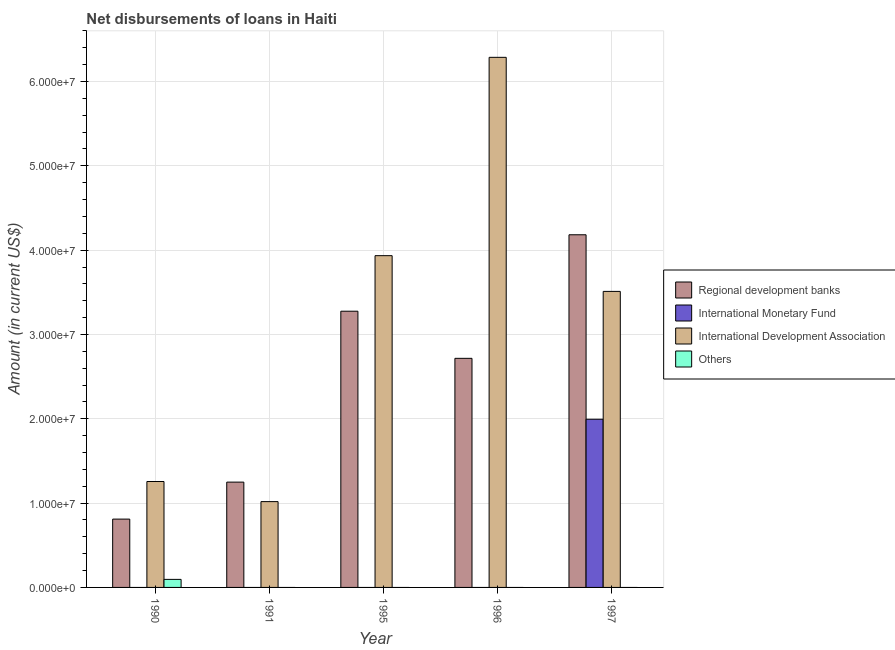How many different coloured bars are there?
Provide a short and direct response. 4. How many groups of bars are there?
Your response must be concise. 5. Are the number of bars per tick equal to the number of legend labels?
Your answer should be very brief. No. Are the number of bars on each tick of the X-axis equal?
Provide a short and direct response. No. How many bars are there on the 2nd tick from the left?
Give a very brief answer. 2. Across all years, what is the maximum amount of loan disimbursed by international monetary fund?
Keep it short and to the point. 1.99e+07. In which year was the amount of loan disimbursed by international monetary fund maximum?
Keep it short and to the point. 1997. What is the total amount of loan disimbursed by international monetary fund in the graph?
Keep it short and to the point. 1.99e+07. What is the difference between the amount of loan disimbursed by regional development banks in 1990 and that in 1991?
Your response must be concise. -4.38e+06. What is the difference between the amount of loan disimbursed by regional development banks in 1995 and the amount of loan disimbursed by international monetary fund in 1990?
Ensure brevity in your answer.  2.47e+07. What is the average amount of loan disimbursed by regional development banks per year?
Make the answer very short. 2.45e+07. What is the ratio of the amount of loan disimbursed by regional development banks in 1995 to that in 1997?
Ensure brevity in your answer.  0.78. Is the amount of loan disimbursed by international development association in 1996 less than that in 1997?
Your answer should be very brief. No. Is the difference between the amount of loan disimbursed by international development association in 1991 and 1995 greater than the difference between the amount of loan disimbursed by international monetary fund in 1991 and 1995?
Your response must be concise. No. What is the difference between the highest and the second highest amount of loan disimbursed by international development association?
Your answer should be compact. 2.35e+07. What is the difference between the highest and the lowest amount of loan disimbursed by international monetary fund?
Your response must be concise. 1.99e+07. Is the sum of the amount of loan disimbursed by international development association in 1991 and 1995 greater than the maximum amount of loan disimbursed by international monetary fund across all years?
Offer a very short reply. No. How many bars are there?
Your answer should be compact. 12. Are all the bars in the graph horizontal?
Give a very brief answer. No. How many years are there in the graph?
Provide a succinct answer. 5. What is the difference between two consecutive major ticks on the Y-axis?
Your response must be concise. 1.00e+07. Are the values on the major ticks of Y-axis written in scientific E-notation?
Keep it short and to the point. Yes. Does the graph contain any zero values?
Your answer should be compact. Yes. Does the graph contain grids?
Make the answer very short. Yes. Where does the legend appear in the graph?
Give a very brief answer. Center right. How many legend labels are there?
Make the answer very short. 4. How are the legend labels stacked?
Your answer should be very brief. Vertical. What is the title of the graph?
Make the answer very short. Net disbursements of loans in Haiti. Does "Australia" appear as one of the legend labels in the graph?
Make the answer very short. No. What is the label or title of the X-axis?
Your answer should be very brief. Year. What is the Amount (in current US$) of Regional development banks in 1990?
Provide a short and direct response. 8.10e+06. What is the Amount (in current US$) of International Development Association in 1990?
Your response must be concise. 1.26e+07. What is the Amount (in current US$) in Others in 1990?
Keep it short and to the point. 9.54e+05. What is the Amount (in current US$) in Regional development banks in 1991?
Your response must be concise. 1.25e+07. What is the Amount (in current US$) of International Development Association in 1991?
Your response must be concise. 1.02e+07. What is the Amount (in current US$) in Others in 1991?
Your response must be concise. 0. What is the Amount (in current US$) in Regional development banks in 1995?
Make the answer very short. 3.28e+07. What is the Amount (in current US$) of International Development Association in 1995?
Your response must be concise. 3.93e+07. What is the Amount (in current US$) in Regional development banks in 1996?
Your response must be concise. 2.72e+07. What is the Amount (in current US$) in International Development Association in 1996?
Ensure brevity in your answer.  6.29e+07. What is the Amount (in current US$) of Others in 1996?
Keep it short and to the point. 0. What is the Amount (in current US$) in Regional development banks in 1997?
Provide a short and direct response. 4.18e+07. What is the Amount (in current US$) of International Monetary Fund in 1997?
Your response must be concise. 1.99e+07. What is the Amount (in current US$) of International Development Association in 1997?
Make the answer very short. 3.51e+07. Across all years, what is the maximum Amount (in current US$) of Regional development banks?
Give a very brief answer. 4.18e+07. Across all years, what is the maximum Amount (in current US$) of International Monetary Fund?
Your answer should be compact. 1.99e+07. Across all years, what is the maximum Amount (in current US$) of International Development Association?
Provide a short and direct response. 6.29e+07. Across all years, what is the maximum Amount (in current US$) in Others?
Make the answer very short. 9.54e+05. Across all years, what is the minimum Amount (in current US$) in Regional development banks?
Your response must be concise. 8.10e+06. Across all years, what is the minimum Amount (in current US$) of International Development Association?
Give a very brief answer. 1.02e+07. What is the total Amount (in current US$) of Regional development banks in the graph?
Make the answer very short. 1.22e+08. What is the total Amount (in current US$) of International Monetary Fund in the graph?
Offer a very short reply. 1.99e+07. What is the total Amount (in current US$) in International Development Association in the graph?
Provide a succinct answer. 1.60e+08. What is the total Amount (in current US$) in Others in the graph?
Give a very brief answer. 9.54e+05. What is the difference between the Amount (in current US$) of Regional development banks in 1990 and that in 1991?
Provide a succinct answer. -4.38e+06. What is the difference between the Amount (in current US$) in International Development Association in 1990 and that in 1991?
Your response must be concise. 2.38e+06. What is the difference between the Amount (in current US$) in Regional development banks in 1990 and that in 1995?
Give a very brief answer. -2.47e+07. What is the difference between the Amount (in current US$) in International Development Association in 1990 and that in 1995?
Offer a terse response. -2.68e+07. What is the difference between the Amount (in current US$) of Regional development banks in 1990 and that in 1996?
Your response must be concise. -1.91e+07. What is the difference between the Amount (in current US$) of International Development Association in 1990 and that in 1996?
Give a very brief answer. -5.03e+07. What is the difference between the Amount (in current US$) of Regional development banks in 1990 and that in 1997?
Ensure brevity in your answer.  -3.37e+07. What is the difference between the Amount (in current US$) in International Development Association in 1990 and that in 1997?
Your response must be concise. -2.25e+07. What is the difference between the Amount (in current US$) in Regional development banks in 1991 and that in 1995?
Provide a short and direct response. -2.03e+07. What is the difference between the Amount (in current US$) of International Development Association in 1991 and that in 1995?
Provide a short and direct response. -2.92e+07. What is the difference between the Amount (in current US$) in Regional development banks in 1991 and that in 1996?
Offer a very short reply. -1.47e+07. What is the difference between the Amount (in current US$) in International Development Association in 1991 and that in 1996?
Provide a short and direct response. -5.27e+07. What is the difference between the Amount (in current US$) in Regional development banks in 1991 and that in 1997?
Provide a succinct answer. -2.93e+07. What is the difference between the Amount (in current US$) of International Development Association in 1991 and that in 1997?
Your response must be concise. -2.49e+07. What is the difference between the Amount (in current US$) in Regional development banks in 1995 and that in 1996?
Offer a terse response. 5.59e+06. What is the difference between the Amount (in current US$) of International Development Association in 1995 and that in 1996?
Your response must be concise. -2.35e+07. What is the difference between the Amount (in current US$) in Regional development banks in 1995 and that in 1997?
Your answer should be very brief. -9.07e+06. What is the difference between the Amount (in current US$) in International Development Association in 1995 and that in 1997?
Give a very brief answer. 4.24e+06. What is the difference between the Amount (in current US$) of Regional development banks in 1996 and that in 1997?
Make the answer very short. -1.47e+07. What is the difference between the Amount (in current US$) in International Development Association in 1996 and that in 1997?
Your answer should be very brief. 2.78e+07. What is the difference between the Amount (in current US$) of Regional development banks in 1990 and the Amount (in current US$) of International Development Association in 1991?
Your response must be concise. -2.07e+06. What is the difference between the Amount (in current US$) in Regional development banks in 1990 and the Amount (in current US$) in International Development Association in 1995?
Give a very brief answer. -3.12e+07. What is the difference between the Amount (in current US$) in Regional development banks in 1990 and the Amount (in current US$) in International Development Association in 1996?
Your answer should be very brief. -5.48e+07. What is the difference between the Amount (in current US$) of Regional development banks in 1990 and the Amount (in current US$) of International Monetary Fund in 1997?
Give a very brief answer. -1.18e+07. What is the difference between the Amount (in current US$) in Regional development banks in 1990 and the Amount (in current US$) in International Development Association in 1997?
Your answer should be very brief. -2.70e+07. What is the difference between the Amount (in current US$) in Regional development banks in 1991 and the Amount (in current US$) in International Development Association in 1995?
Keep it short and to the point. -2.69e+07. What is the difference between the Amount (in current US$) in Regional development banks in 1991 and the Amount (in current US$) in International Development Association in 1996?
Ensure brevity in your answer.  -5.04e+07. What is the difference between the Amount (in current US$) in Regional development banks in 1991 and the Amount (in current US$) in International Monetary Fund in 1997?
Make the answer very short. -7.46e+06. What is the difference between the Amount (in current US$) in Regional development banks in 1991 and the Amount (in current US$) in International Development Association in 1997?
Offer a very short reply. -2.26e+07. What is the difference between the Amount (in current US$) in Regional development banks in 1995 and the Amount (in current US$) in International Development Association in 1996?
Your answer should be compact. -3.01e+07. What is the difference between the Amount (in current US$) in Regional development banks in 1995 and the Amount (in current US$) in International Monetary Fund in 1997?
Your response must be concise. 1.28e+07. What is the difference between the Amount (in current US$) in Regional development banks in 1995 and the Amount (in current US$) in International Development Association in 1997?
Offer a very short reply. -2.35e+06. What is the difference between the Amount (in current US$) in Regional development banks in 1996 and the Amount (in current US$) in International Monetary Fund in 1997?
Make the answer very short. 7.22e+06. What is the difference between the Amount (in current US$) in Regional development banks in 1996 and the Amount (in current US$) in International Development Association in 1997?
Your answer should be compact. -7.94e+06. What is the average Amount (in current US$) of Regional development banks per year?
Your response must be concise. 2.45e+07. What is the average Amount (in current US$) in International Monetary Fund per year?
Make the answer very short. 3.99e+06. What is the average Amount (in current US$) of International Development Association per year?
Offer a very short reply. 3.20e+07. What is the average Amount (in current US$) in Others per year?
Give a very brief answer. 1.91e+05. In the year 1990, what is the difference between the Amount (in current US$) of Regional development banks and Amount (in current US$) of International Development Association?
Give a very brief answer. -4.46e+06. In the year 1990, what is the difference between the Amount (in current US$) of Regional development banks and Amount (in current US$) of Others?
Offer a terse response. 7.15e+06. In the year 1990, what is the difference between the Amount (in current US$) of International Development Association and Amount (in current US$) of Others?
Your answer should be very brief. 1.16e+07. In the year 1991, what is the difference between the Amount (in current US$) in Regional development banks and Amount (in current US$) in International Development Association?
Keep it short and to the point. 2.31e+06. In the year 1995, what is the difference between the Amount (in current US$) of Regional development banks and Amount (in current US$) of International Development Association?
Make the answer very short. -6.59e+06. In the year 1996, what is the difference between the Amount (in current US$) in Regional development banks and Amount (in current US$) in International Development Association?
Keep it short and to the point. -3.57e+07. In the year 1997, what is the difference between the Amount (in current US$) in Regional development banks and Amount (in current US$) in International Monetary Fund?
Keep it short and to the point. 2.19e+07. In the year 1997, what is the difference between the Amount (in current US$) of Regional development banks and Amount (in current US$) of International Development Association?
Give a very brief answer. 6.72e+06. In the year 1997, what is the difference between the Amount (in current US$) of International Monetary Fund and Amount (in current US$) of International Development Association?
Keep it short and to the point. -1.52e+07. What is the ratio of the Amount (in current US$) in Regional development banks in 1990 to that in 1991?
Offer a terse response. 0.65. What is the ratio of the Amount (in current US$) in International Development Association in 1990 to that in 1991?
Ensure brevity in your answer.  1.23. What is the ratio of the Amount (in current US$) in Regional development banks in 1990 to that in 1995?
Make the answer very short. 0.25. What is the ratio of the Amount (in current US$) in International Development Association in 1990 to that in 1995?
Your answer should be compact. 0.32. What is the ratio of the Amount (in current US$) of Regional development banks in 1990 to that in 1996?
Your response must be concise. 0.3. What is the ratio of the Amount (in current US$) of International Development Association in 1990 to that in 1996?
Your answer should be very brief. 0.2. What is the ratio of the Amount (in current US$) in Regional development banks in 1990 to that in 1997?
Your response must be concise. 0.19. What is the ratio of the Amount (in current US$) of International Development Association in 1990 to that in 1997?
Make the answer very short. 0.36. What is the ratio of the Amount (in current US$) of Regional development banks in 1991 to that in 1995?
Offer a very short reply. 0.38. What is the ratio of the Amount (in current US$) in International Development Association in 1991 to that in 1995?
Offer a terse response. 0.26. What is the ratio of the Amount (in current US$) of Regional development banks in 1991 to that in 1996?
Your answer should be very brief. 0.46. What is the ratio of the Amount (in current US$) in International Development Association in 1991 to that in 1996?
Your answer should be compact. 0.16. What is the ratio of the Amount (in current US$) in Regional development banks in 1991 to that in 1997?
Your answer should be very brief. 0.3. What is the ratio of the Amount (in current US$) of International Development Association in 1991 to that in 1997?
Provide a short and direct response. 0.29. What is the ratio of the Amount (in current US$) in Regional development banks in 1995 to that in 1996?
Offer a very short reply. 1.21. What is the ratio of the Amount (in current US$) in International Development Association in 1995 to that in 1996?
Offer a terse response. 0.63. What is the ratio of the Amount (in current US$) of Regional development banks in 1995 to that in 1997?
Ensure brevity in your answer.  0.78. What is the ratio of the Amount (in current US$) in International Development Association in 1995 to that in 1997?
Offer a very short reply. 1.12. What is the ratio of the Amount (in current US$) in Regional development banks in 1996 to that in 1997?
Give a very brief answer. 0.65. What is the ratio of the Amount (in current US$) in International Development Association in 1996 to that in 1997?
Offer a very short reply. 1.79. What is the difference between the highest and the second highest Amount (in current US$) of Regional development banks?
Your answer should be very brief. 9.07e+06. What is the difference between the highest and the second highest Amount (in current US$) in International Development Association?
Your response must be concise. 2.35e+07. What is the difference between the highest and the lowest Amount (in current US$) in Regional development banks?
Give a very brief answer. 3.37e+07. What is the difference between the highest and the lowest Amount (in current US$) in International Monetary Fund?
Offer a terse response. 1.99e+07. What is the difference between the highest and the lowest Amount (in current US$) of International Development Association?
Provide a short and direct response. 5.27e+07. What is the difference between the highest and the lowest Amount (in current US$) of Others?
Give a very brief answer. 9.54e+05. 